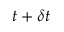<formula> <loc_0><loc_0><loc_500><loc_500>t + \delta t</formula> 